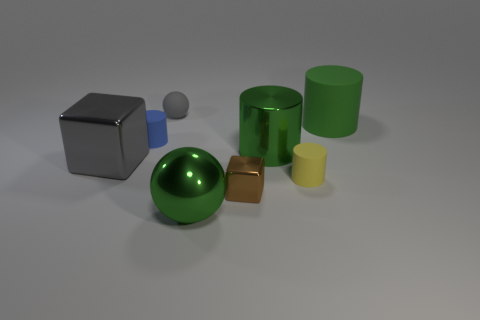Subtract all large green shiny cylinders. How many cylinders are left? 3 Add 2 large green metallic cylinders. How many objects exist? 10 Subtract all red balls. How many green cylinders are left? 2 Subtract all cubes. How many objects are left? 6 Subtract 3 cylinders. How many cylinders are left? 1 Subtract all blue cylinders. How many cylinders are left? 3 Subtract 0 purple cubes. How many objects are left? 8 Subtract all blue spheres. Subtract all brown cubes. How many spheres are left? 2 Subtract all large yellow metallic cubes. Subtract all brown things. How many objects are left? 7 Add 7 green shiny cylinders. How many green shiny cylinders are left? 8 